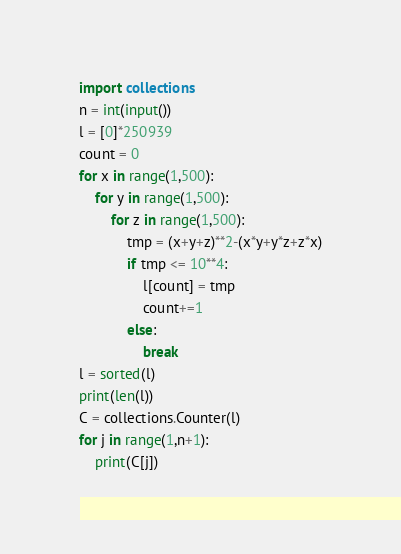<code> <loc_0><loc_0><loc_500><loc_500><_Python_>import collections
n = int(input())
l = [0]*250939
count = 0
for x in range(1,500):
    for y in range(1,500):
        for z in range(1,500):
            tmp = (x+y+z)**2-(x*y+y*z+z*x)
            if tmp <= 10**4:
                l[count] = tmp
                count+=1
            else:
                break
l = sorted(l)
print(len(l))
C = collections.Counter(l)
for j in range(1,n+1):
    print(C[j])</code> 